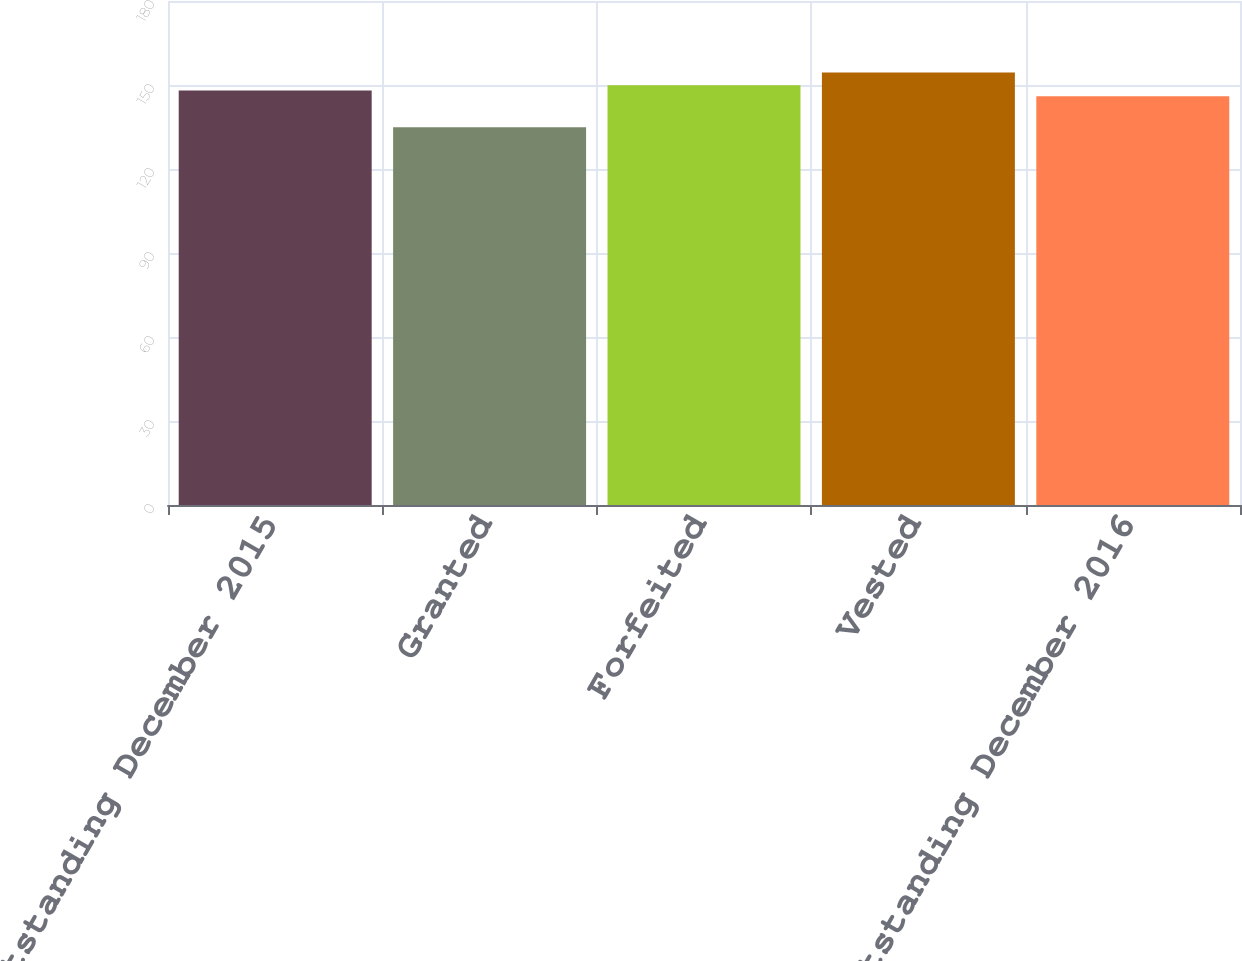Convert chart. <chart><loc_0><loc_0><loc_500><loc_500><bar_chart><fcel>Outstanding December 2015<fcel>Granted<fcel>Forfeited<fcel>Vested<fcel>Outstanding December 2016<nl><fcel>148<fcel>134.9<fcel>149.95<fcel>154.44<fcel>145.97<nl></chart> 